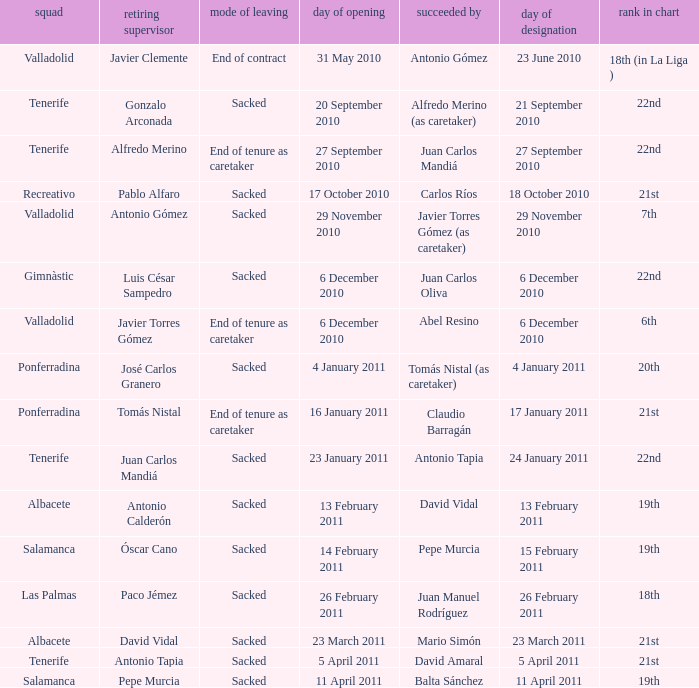How many teams had an appointment date of 11 april 2011 1.0. 